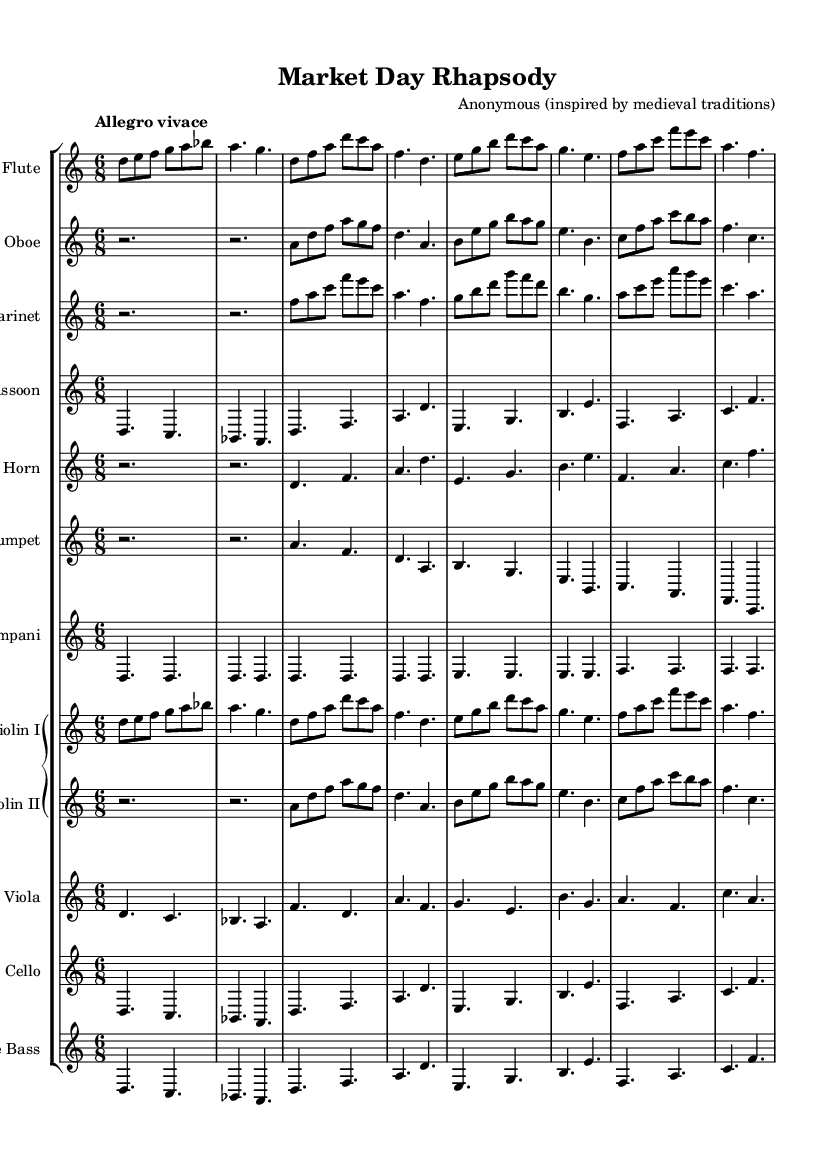What is the key signature of this music? The key signature is D Dorian, which is indicated at the beginning of the score. D Dorian has two sharps, F# and C#.
Answer: D Dorian What is the time signature of the piece? The time signature is listed at the beginning of the score as 6/8. This means there are six eighth notes per measure, often giving the music a lively, dance-like feel.
Answer: 6/8 What is the tempo marking for this composition? The tempo marking states "Allegro vivace," which indicates a lively and fast tempo. This tempo marking suggests that the music should be played quickly and energetically.
Answer: Allegro vivace Which instrument plays the melody predominantly? In this composition, the flute plays the predominant melody throughout the piece, making it a leading melodic voice among the instruments.
Answer: Flute How many measures of music are present in total? To determine the total number of measures, one must count the distinct measures visible in the sheet music. In this case, the score comprises a specific number of measures which totals to 16.
Answer: 16 Which instruments are transposed down a whole step? The instruments that are transposed down a whole step include the clarinet in B-flat and the trumpet in B-flat, as indicated by the transposition notes in the score.
Answer: Clarinet, Trumpet What musical texture is predominantly used in this piece? The piece features a homophonic texture, characterized by one primary melody (often in the flute) accompanied by harmonies from other instruments, which is a common characteristic in orchestral compositions.
Answer: Homophonic 